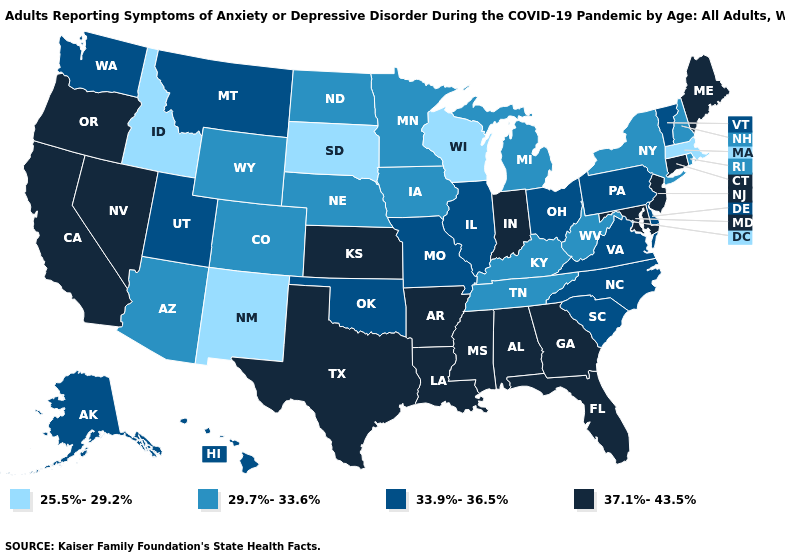Does Washington have the highest value in the USA?
Concise answer only. No. Name the states that have a value in the range 33.9%-36.5%?
Concise answer only. Alaska, Delaware, Hawaii, Illinois, Missouri, Montana, North Carolina, Ohio, Oklahoma, Pennsylvania, South Carolina, Utah, Vermont, Virginia, Washington. Name the states that have a value in the range 33.9%-36.5%?
Keep it brief. Alaska, Delaware, Hawaii, Illinois, Missouri, Montana, North Carolina, Ohio, Oklahoma, Pennsylvania, South Carolina, Utah, Vermont, Virginia, Washington. Name the states that have a value in the range 29.7%-33.6%?
Be succinct. Arizona, Colorado, Iowa, Kentucky, Michigan, Minnesota, Nebraska, New Hampshire, New York, North Dakota, Rhode Island, Tennessee, West Virginia, Wyoming. Does Maryland have the highest value in the South?
Give a very brief answer. Yes. How many symbols are there in the legend?
Quick response, please. 4. What is the value of North Dakota?
Keep it brief. 29.7%-33.6%. What is the lowest value in the West?
Be succinct. 25.5%-29.2%. What is the value of New Mexico?
Concise answer only. 25.5%-29.2%. What is the lowest value in the South?
Write a very short answer. 29.7%-33.6%. What is the highest value in the MidWest ?
Give a very brief answer. 37.1%-43.5%. What is the value of Texas?
Give a very brief answer. 37.1%-43.5%. Among the states that border Indiana , does Ohio have the lowest value?
Concise answer only. No. How many symbols are there in the legend?
Give a very brief answer. 4. Is the legend a continuous bar?
Be succinct. No. 